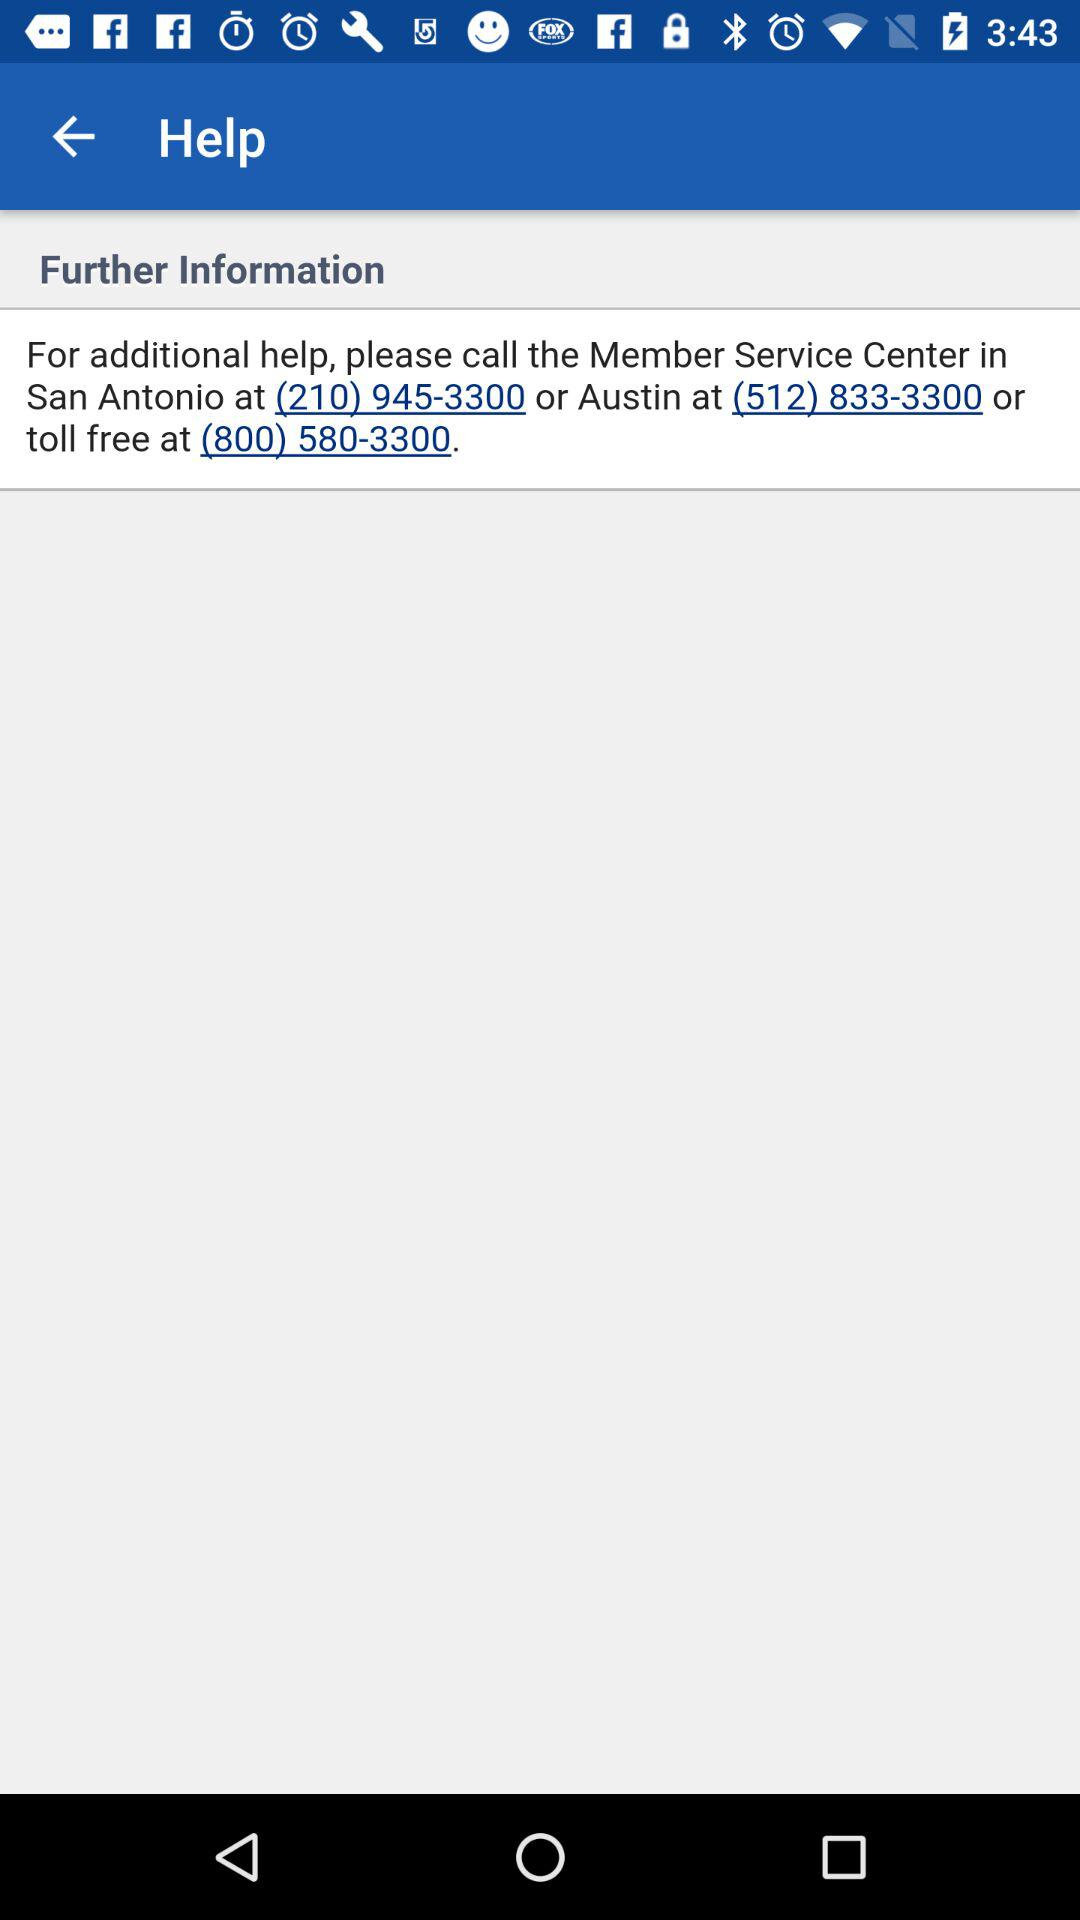How many phone numbers are provided for additional help?
Answer the question using a single word or phrase. 3 